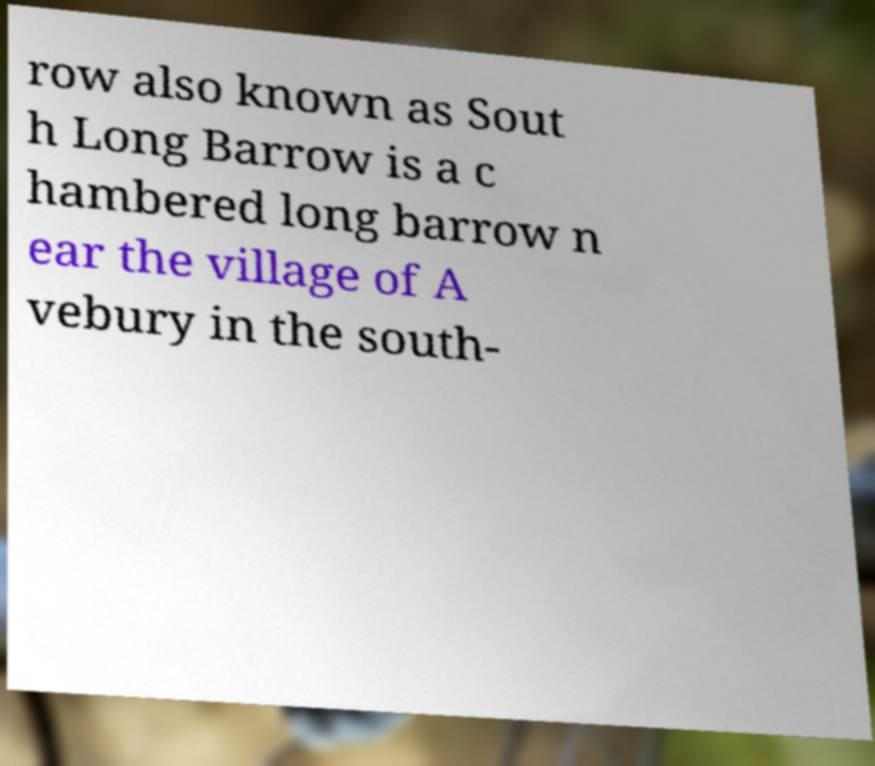Could you assist in decoding the text presented in this image and type it out clearly? row also known as Sout h Long Barrow is a c hambered long barrow n ear the village of A vebury in the south- 